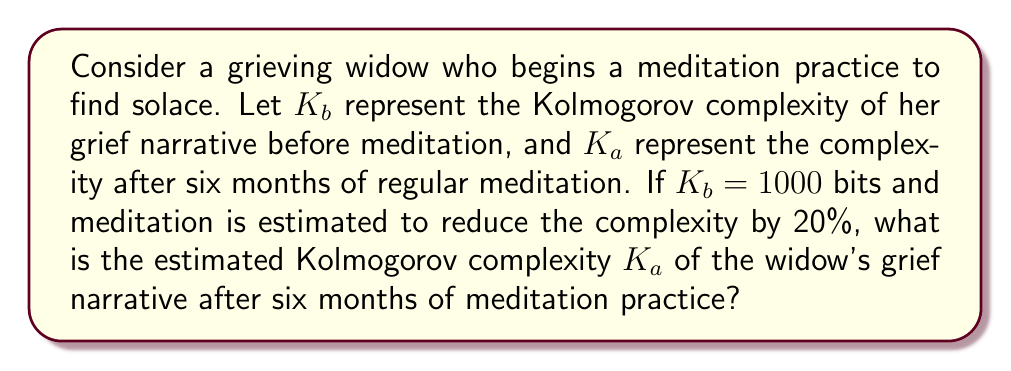Can you solve this math problem? To solve this problem, we need to understand the concept of Kolmogorov complexity and how it relates to personal narratives. Kolmogorov complexity is a measure of the computational resources needed to specify an object, in this case, a personal grief narrative.

Given:
- $K_b = 1000$ bits (Kolmogorov complexity before meditation)
- Meditation is estimated to reduce the complexity by 20%

Steps to solve:

1. Calculate the reduction in complexity:
   $$\text{Reduction} = K_b \times 20\% = 1000 \times 0.20 = 200 \text{ bits}$$

2. Subtract the reduction from the original complexity:
   $$K_a = K_b - \text{Reduction} = 1000 - 200 = 800 \text{ bits}$$

The reduction in Kolmogorov complexity after meditation practice can be interpreted as the widow's grief narrative becoming more structured, coherent, and possibly more concise due to the emotional processing and healing facilitated by meditation.
Answer: $K_a = 800 \text{ bits}$ 